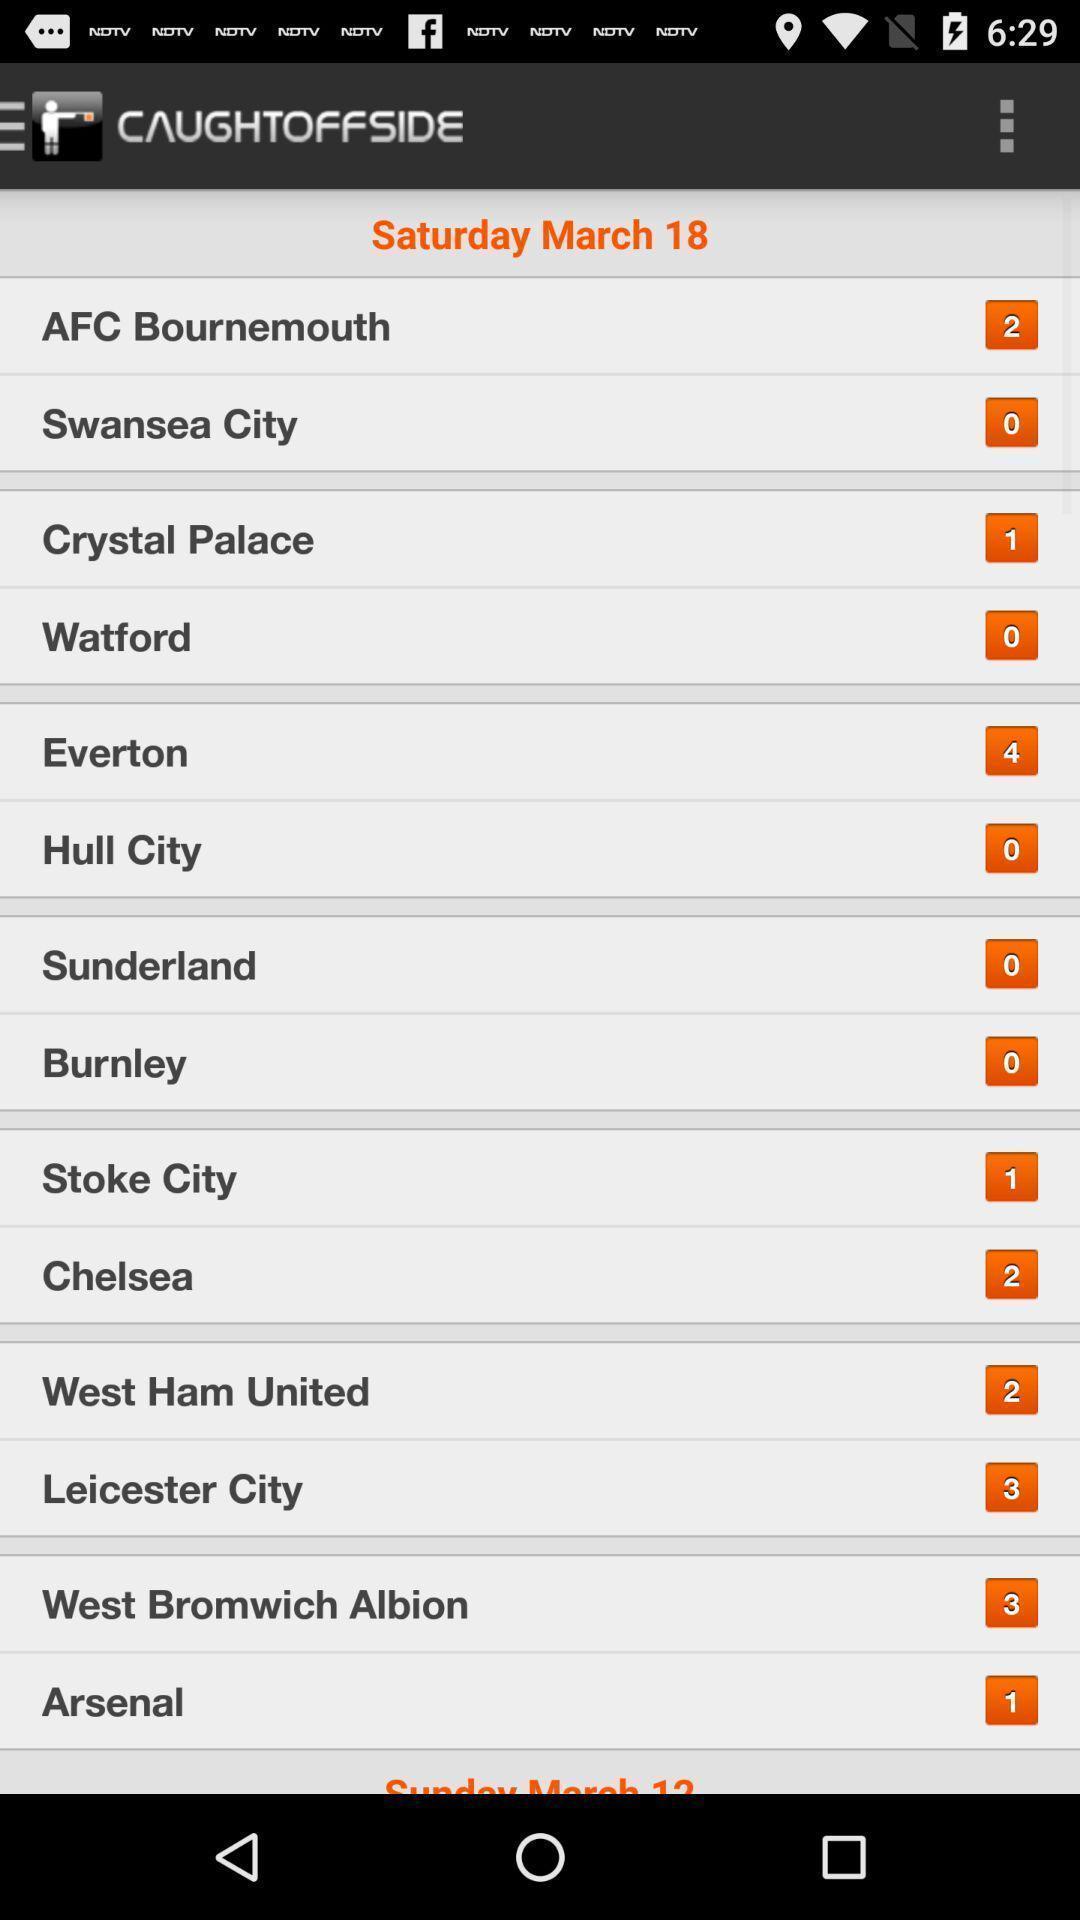What can you discern from this picture? Screen displaying multiple football teams. 